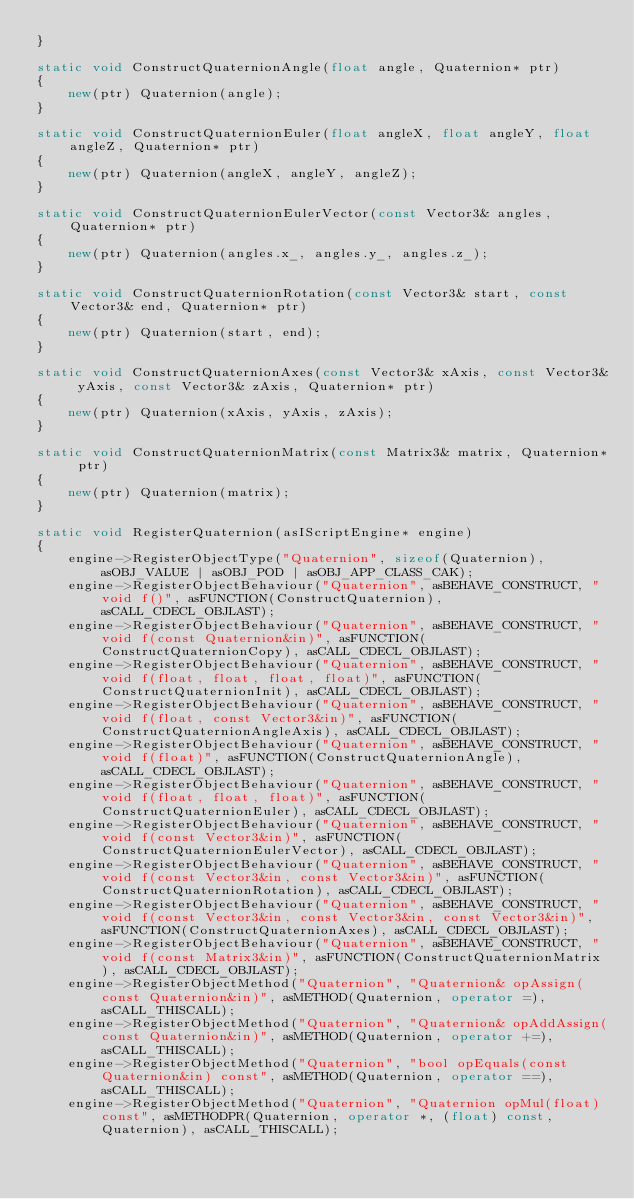Convert code to text. <code><loc_0><loc_0><loc_500><loc_500><_C++_>}

static void ConstructQuaternionAngle(float angle, Quaternion* ptr)
{
    new(ptr) Quaternion(angle);
}

static void ConstructQuaternionEuler(float angleX, float angleY, float angleZ, Quaternion* ptr)
{
    new(ptr) Quaternion(angleX, angleY, angleZ);
}

static void ConstructQuaternionEulerVector(const Vector3& angles, Quaternion* ptr)
{
    new(ptr) Quaternion(angles.x_, angles.y_, angles.z_);
}

static void ConstructQuaternionRotation(const Vector3& start, const Vector3& end, Quaternion* ptr)
{
    new(ptr) Quaternion(start, end);
}

static void ConstructQuaternionAxes(const Vector3& xAxis, const Vector3& yAxis, const Vector3& zAxis, Quaternion* ptr)
{
    new(ptr) Quaternion(xAxis, yAxis, zAxis);
}

static void ConstructQuaternionMatrix(const Matrix3& matrix, Quaternion* ptr)
{
    new(ptr) Quaternion(matrix);
}

static void RegisterQuaternion(asIScriptEngine* engine)
{
    engine->RegisterObjectType("Quaternion", sizeof(Quaternion), asOBJ_VALUE | asOBJ_POD | asOBJ_APP_CLASS_CAK);
    engine->RegisterObjectBehaviour("Quaternion", asBEHAVE_CONSTRUCT, "void f()", asFUNCTION(ConstructQuaternion), asCALL_CDECL_OBJLAST);
    engine->RegisterObjectBehaviour("Quaternion", asBEHAVE_CONSTRUCT, "void f(const Quaternion&in)", asFUNCTION(ConstructQuaternionCopy), asCALL_CDECL_OBJLAST);
    engine->RegisterObjectBehaviour("Quaternion", asBEHAVE_CONSTRUCT, "void f(float, float, float, float)", asFUNCTION(ConstructQuaternionInit), asCALL_CDECL_OBJLAST);
    engine->RegisterObjectBehaviour("Quaternion", asBEHAVE_CONSTRUCT, "void f(float, const Vector3&in)", asFUNCTION(ConstructQuaternionAngleAxis), asCALL_CDECL_OBJLAST);
    engine->RegisterObjectBehaviour("Quaternion", asBEHAVE_CONSTRUCT, "void f(float)", asFUNCTION(ConstructQuaternionAngle), asCALL_CDECL_OBJLAST);
    engine->RegisterObjectBehaviour("Quaternion", asBEHAVE_CONSTRUCT, "void f(float, float, float)", asFUNCTION(ConstructQuaternionEuler), asCALL_CDECL_OBJLAST);
    engine->RegisterObjectBehaviour("Quaternion", asBEHAVE_CONSTRUCT, "void f(const Vector3&in)", asFUNCTION(ConstructQuaternionEulerVector), asCALL_CDECL_OBJLAST);
    engine->RegisterObjectBehaviour("Quaternion", asBEHAVE_CONSTRUCT, "void f(const Vector3&in, const Vector3&in)", asFUNCTION(ConstructQuaternionRotation), asCALL_CDECL_OBJLAST);
    engine->RegisterObjectBehaviour("Quaternion", asBEHAVE_CONSTRUCT, "void f(const Vector3&in, const Vector3&in, const Vector3&in)", asFUNCTION(ConstructQuaternionAxes), asCALL_CDECL_OBJLAST);
    engine->RegisterObjectBehaviour("Quaternion", asBEHAVE_CONSTRUCT, "void f(const Matrix3&in)", asFUNCTION(ConstructQuaternionMatrix), asCALL_CDECL_OBJLAST);
    engine->RegisterObjectMethod("Quaternion", "Quaternion& opAssign(const Quaternion&in)", asMETHOD(Quaternion, operator =), asCALL_THISCALL);
    engine->RegisterObjectMethod("Quaternion", "Quaternion& opAddAssign(const Quaternion&in)", asMETHOD(Quaternion, operator +=), asCALL_THISCALL);
    engine->RegisterObjectMethod("Quaternion", "bool opEquals(const Quaternion&in) const", asMETHOD(Quaternion, operator ==), asCALL_THISCALL);
    engine->RegisterObjectMethod("Quaternion", "Quaternion opMul(float) const", asMETHODPR(Quaternion, operator *, (float) const, Quaternion), asCALL_THISCALL);</code> 